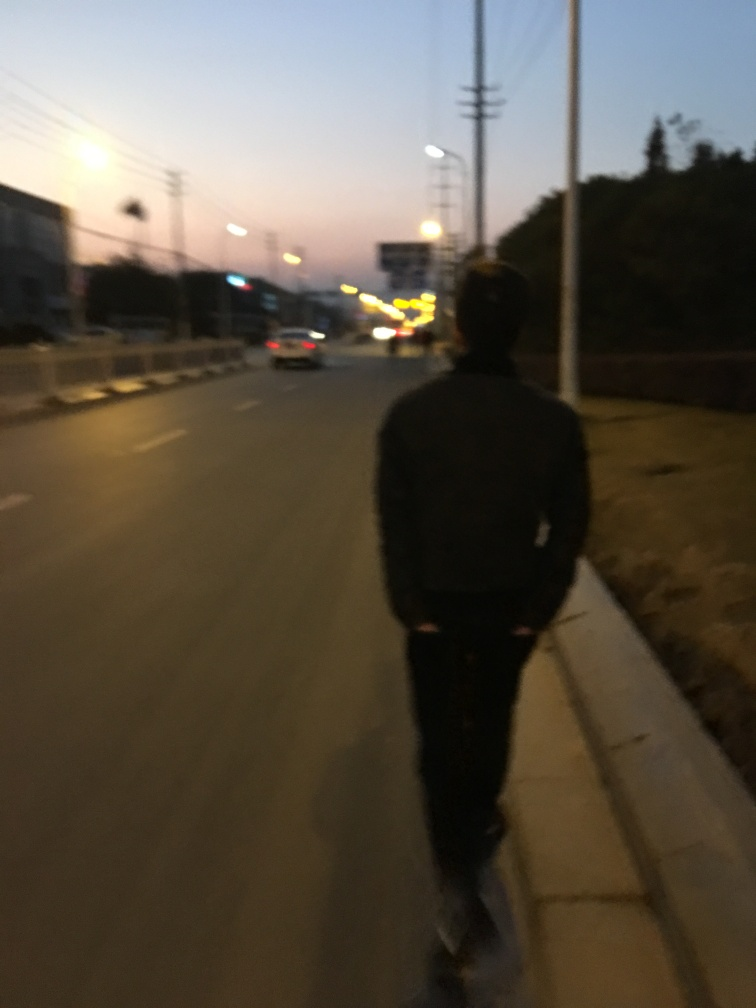What can you infer about the person in the image? The person in the image is captured from behind, walking along what looks to be a roadside pavement. The individual's attire and posture suggest a casual, unhurried demeanor, which may imply that they're taking a leisurely walk or heading home after a day's activities. 